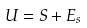<formula> <loc_0><loc_0><loc_500><loc_500>U = S + E _ { s }</formula> 